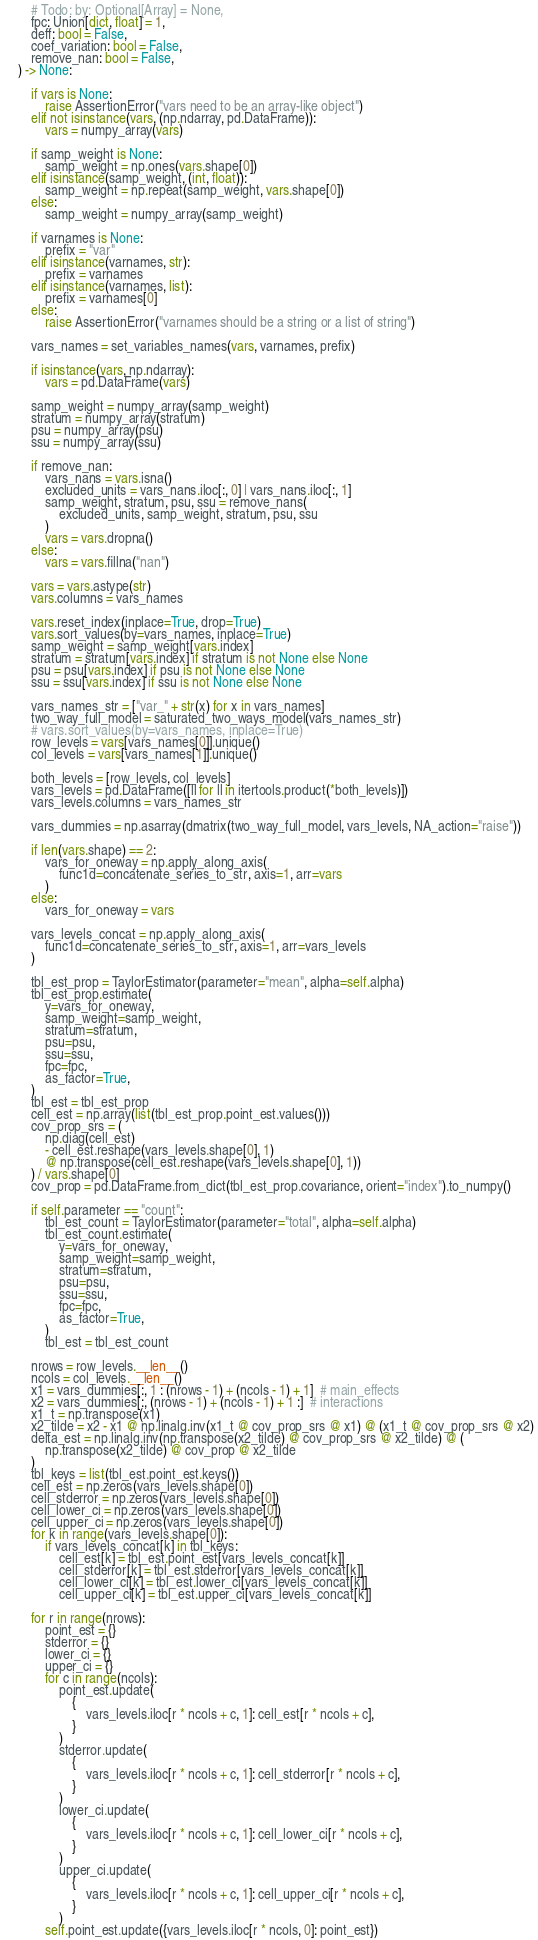<code> <loc_0><loc_0><loc_500><loc_500><_Python_>        # Todo: by: Optional[Array] = None,
        fpc: Union[dict, float] = 1,
        deff: bool = False,
        coef_variation: bool = False,
        remove_nan: bool = False,
    ) -> None:

        if vars is None:
            raise AssertionError("vars need to be an array-like object")
        elif not isinstance(vars, (np.ndarray, pd.DataFrame)):
            vars = numpy_array(vars)

        if samp_weight is None:
            samp_weight = np.ones(vars.shape[0])
        elif isinstance(samp_weight, (int, float)):
            samp_weight = np.repeat(samp_weight, vars.shape[0])
        else:
            samp_weight = numpy_array(samp_weight)

        if varnames is None:
            prefix = "var"
        elif isinstance(varnames, str):
            prefix = varnames
        elif isinstance(varnames, list):
            prefix = varnames[0]
        else:
            raise AssertionError("varnames should be a string or a list of string")

        vars_names = set_variables_names(vars, varnames, prefix)

        if isinstance(vars, np.ndarray):
            vars = pd.DataFrame(vars)

        samp_weight = numpy_array(samp_weight)
        stratum = numpy_array(stratum)
        psu = numpy_array(psu)
        ssu = numpy_array(ssu)

        if remove_nan:
            vars_nans = vars.isna()
            excluded_units = vars_nans.iloc[:, 0] | vars_nans.iloc[:, 1]
            samp_weight, stratum, psu, ssu = remove_nans(
                excluded_units, samp_weight, stratum, psu, ssu
            )
            vars = vars.dropna()
        else:
            vars = vars.fillna("nan")

        vars = vars.astype(str)
        vars.columns = vars_names

        vars.reset_index(inplace=True, drop=True)
        vars.sort_values(by=vars_names, inplace=True)
        samp_weight = samp_weight[vars.index]
        stratum = stratum[vars.index] if stratum is not None else None
        psu = psu[vars.index] if psu is not None else None
        ssu = ssu[vars.index] if ssu is not None else None

        vars_names_str = ["var_" + str(x) for x in vars_names]
        two_way_full_model = saturated_two_ways_model(vars_names_str)
        # vars.sort_values(by=vars_names, inplace=True)
        row_levels = vars[vars_names[0]].unique()
        col_levels = vars[vars_names[1]].unique()

        both_levels = [row_levels, col_levels]
        vars_levels = pd.DataFrame([ll for ll in itertools.product(*both_levels)])
        vars_levels.columns = vars_names_str

        vars_dummies = np.asarray(dmatrix(two_way_full_model, vars_levels, NA_action="raise"))

        if len(vars.shape) == 2:
            vars_for_oneway = np.apply_along_axis(
                func1d=concatenate_series_to_str, axis=1, arr=vars
            )
        else:
            vars_for_oneway = vars

        vars_levels_concat = np.apply_along_axis(
            func1d=concatenate_series_to_str, axis=1, arr=vars_levels
        )

        tbl_est_prop = TaylorEstimator(parameter="mean", alpha=self.alpha)
        tbl_est_prop.estimate(
            y=vars_for_oneway,
            samp_weight=samp_weight,
            stratum=stratum,
            psu=psu,
            ssu=ssu,
            fpc=fpc,
            as_factor=True,
        )
        tbl_est = tbl_est_prop
        cell_est = np.array(list(tbl_est_prop.point_est.values()))
        cov_prop_srs = (
            np.diag(cell_est)
            - cell_est.reshape(vars_levels.shape[0], 1)
            @ np.transpose(cell_est.reshape(vars_levels.shape[0], 1))
        ) / vars.shape[0]
        cov_prop = pd.DataFrame.from_dict(tbl_est_prop.covariance, orient="index").to_numpy()

        if self.parameter == "count":
            tbl_est_count = TaylorEstimator(parameter="total", alpha=self.alpha)
            tbl_est_count.estimate(
                y=vars_for_oneway,
                samp_weight=samp_weight,
                stratum=stratum,
                psu=psu,
                ssu=ssu,
                fpc=fpc,
                as_factor=True,
            )
            tbl_est = tbl_est_count

        nrows = row_levels.__len__()
        ncols = col_levels.__len__()
        x1 = vars_dummies[:, 1 : (nrows - 1) + (ncols - 1) + 1]  # main_effects
        x2 = vars_dummies[:, (nrows - 1) + (ncols - 1) + 1 :]  # interactions
        x1_t = np.transpose(x1)
        x2_tilde = x2 - x1 @ np.linalg.inv(x1_t @ cov_prop_srs @ x1) @ (x1_t @ cov_prop_srs @ x2)
        delta_est = np.linalg.inv(np.transpose(x2_tilde) @ cov_prop_srs @ x2_tilde) @ (
            np.transpose(x2_tilde) @ cov_prop @ x2_tilde
        )
        tbl_keys = list(tbl_est.point_est.keys())
        cell_est = np.zeros(vars_levels.shape[0])
        cell_stderror = np.zeros(vars_levels.shape[0])
        cell_lower_ci = np.zeros(vars_levels.shape[0])
        cell_upper_ci = np.zeros(vars_levels.shape[0])
        for k in range(vars_levels.shape[0]):
            if vars_levels_concat[k] in tbl_keys:
                cell_est[k] = tbl_est.point_est[vars_levels_concat[k]]
                cell_stderror[k] = tbl_est.stderror[vars_levels_concat[k]]
                cell_lower_ci[k] = tbl_est.lower_ci[vars_levels_concat[k]]
                cell_upper_ci[k] = tbl_est.upper_ci[vars_levels_concat[k]]

        for r in range(nrows):
            point_est = {}
            stderror = {}
            lower_ci = {}
            upper_ci = {}
            for c in range(ncols):
                point_est.update(
                    {
                        vars_levels.iloc[r * ncols + c, 1]: cell_est[r * ncols + c],
                    }
                )
                stderror.update(
                    {
                        vars_levels.iloc[r * ncols + c, 1]: cell_stderror[r * ncols + c],
                    }
                )
                lower_ci.update(
                    {
                        vars_levels.iloc[r * ncols + c, 1]: cell_lower_ci[r * ncols + c],
                    }
                )
                upper_ci.update(
                    {
                        vars_levels.iloc[r * ncols + c, 1]: cell_upper_ci[r * ncols + c],
                    }
                )
            self.point_est.update({vars_levels.iloc[r * ncols, 0]: point_est})</code> 